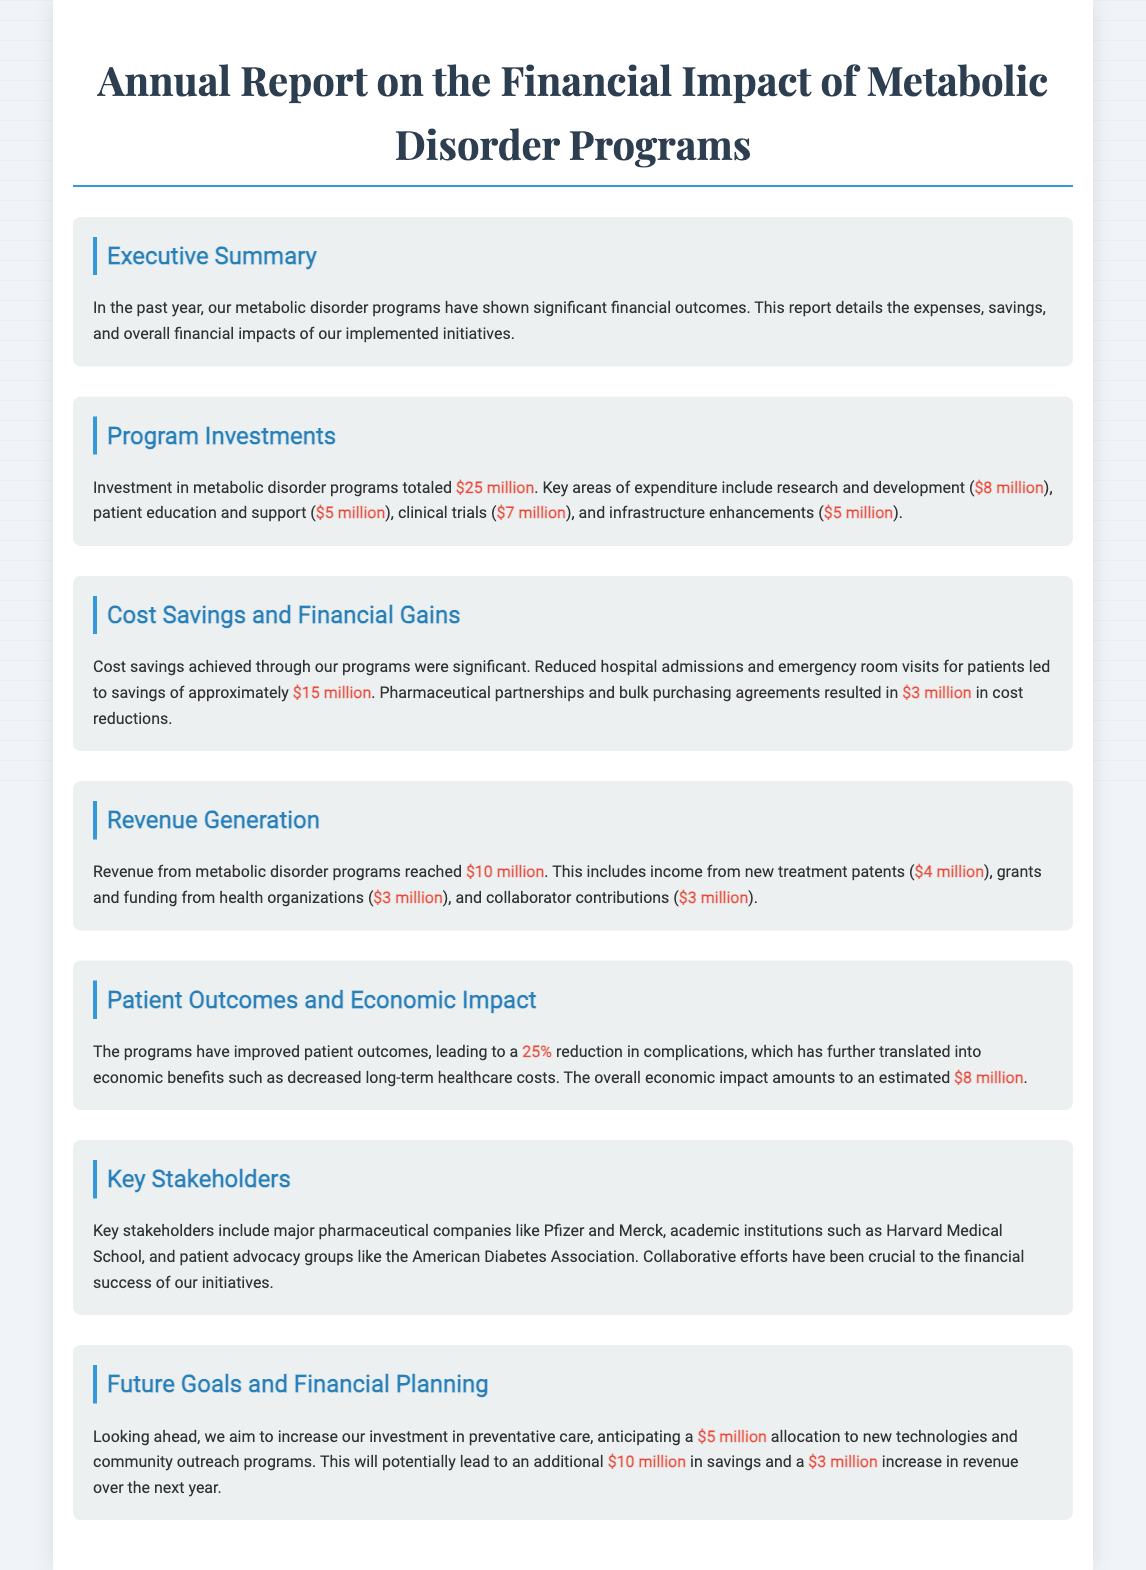What was the total investment in metabolic disorder programs? The total investment is provided in the document, specifically stated as $25 million.
Answer: $25 million How much was spent on research and development? The document specifies that $8 million was spent on research and development within the program investments section.
Answer: $8 million What were the cost savings from reduced hospital admissions? According to the document, the savings achieved from reduced hospital admissions and emergency room visits amounted to approximately $15 million.
Answer: $15 million What is the revenue generated from new treatment patents? Revenue from new treatment patents is detailed in the report and stated as $4 million.
Answer: $4 million What percentage reduction in complications was reported? The document mentions a 25% reduction in complications due to the programs, highlighting improvements in patient outcomes.
Answer: 25% Which pharmaceutical company is listed as a key stakeholder? The document identifies Pfizer as one of the major pharmaceutical companies involved as a key stakeholder in these programs.
Answer: Pfizer What is the anticipated allocation to new technologies and community outreach programs for the next year? The future goals section indicates that there is an anticipated allocation of $5 million for new technologies and community outreach programs.
Answer: $5 million How much revenue is expected from future initiatives? Future projections in the document suggest an expected increase in revenue of $3 million from new initiatives in the upcoming year.
Answer: $3 million 